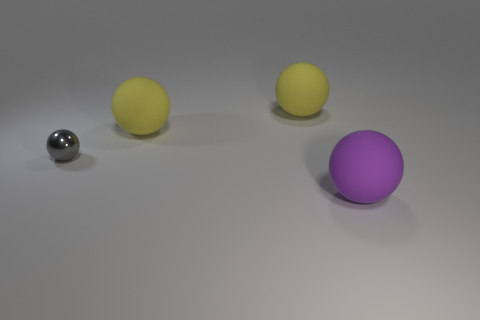Subtract all cyan cubes. How many yellow balls are left? 2 Subtract all tiny gray spheres. How many spheres are left? 3 Subtract all gray spheres. How many spheres are left? 3 Add 3 large purple rubber things. How many objects exist? 7 Subtract all cyan balls. Subtract all purple cylinders. How many balls are left? 4 Add 3 purple spheres. How many purple spheres exist? 4 Subtract 0 purple blocks. How many objects are left? 4 Subtract all small blue metal cubes. Subtract all big purple rubber things. How many objects are left? 3 Add 2 big rubber spheres. How many big rubber spheres are left? 5 